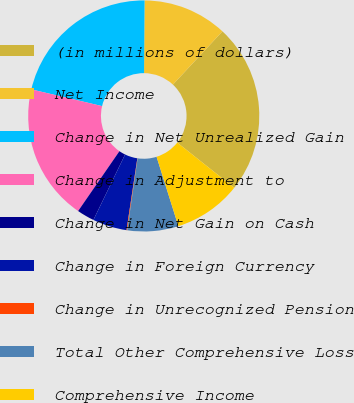Convert chart. <chart><loc_0><loc_0><loc_500><loc_500><pie_chart><fcel>(in millions of dollars)<fcel>Net Income<fcel>Change in Net Unrealized Gain<fcel>Change in Adjustment to<fcel>Change in Net Gain on Cash<fcel>Change in Foreign Currency<fcel>Change in Unrecognized Pension<fcel>Total Other Comprehensive Loss<fcel>Comprehensive Income<nl><fcel>23.76%<fcel>11.81%<fcel>21.42%<fcel>19.08%<fcel>2.44%<fcel>4.79%<fcel>0.1%<fcel>7.13%<fcel>9.47%<nl></chart> 